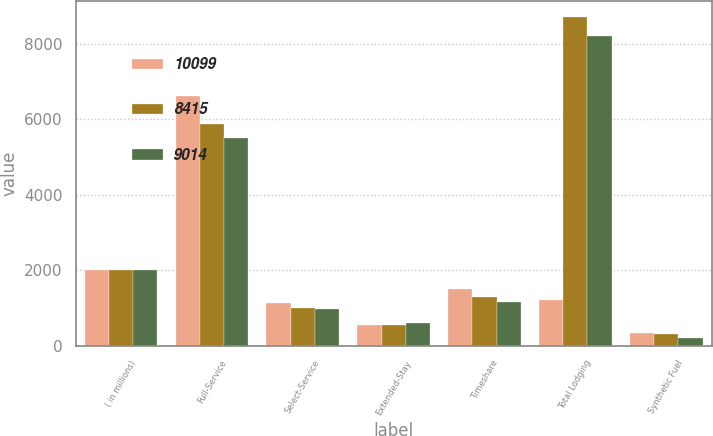Convert chart to OTSL. <chart><loc_0><loc_0><loc_500><loc_500><stacked_bar_chart><ecel><fcel>( in millions)<fcel>Full-Service<fcel>Select-Service<fcel>Extended-Stay<fcel>Timeshare<fcel>Total Lodging<fcel>Synthetic Fuel<nl><fcel>10099<fcel>2004<fcel>6611<fcel>1118<fcel>547<fcel>1502<fcel>1213<fcel>321<nl><fcel>8415<fcel>2003<fcel>5876<fcel>1000<fcel>557<fcel>1279<fcel>8712<fcel>302<nl><fcel>9014<fcel>2002<fcel>5508<fcel>967<fcel>600<fcel>1147<fcel>8222<fcel>193<nl></chart> 